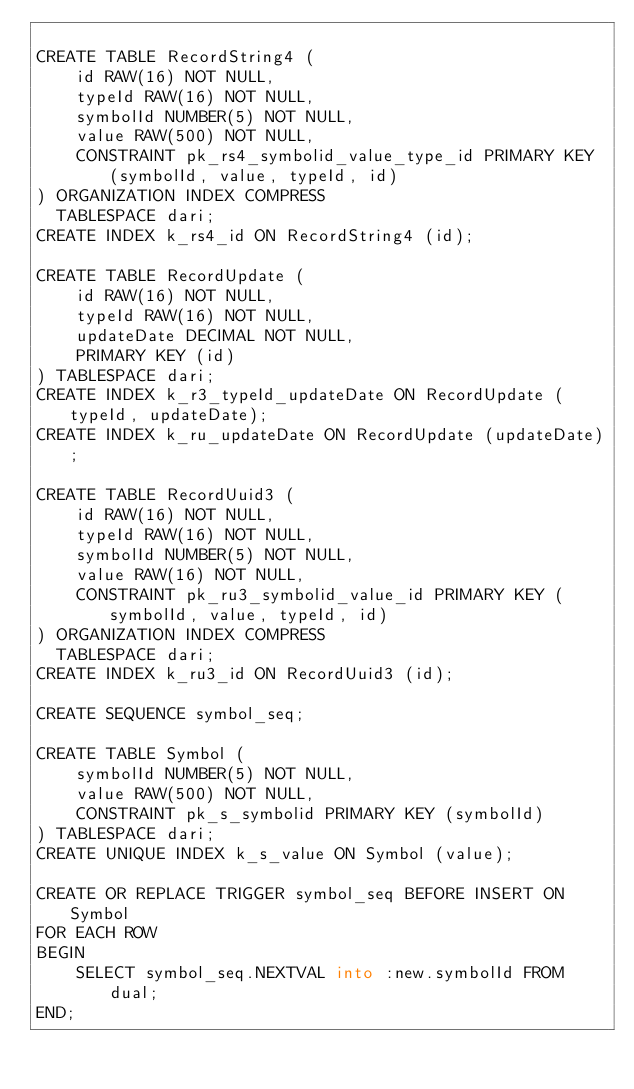Convert code to text. <code><loc_0><loc_0><loc_500><loc_500><_SQL_>
CREATE TABLE RecordString4 (
    id RAW(16) NOT NULL,
    typeId RAW(16) NOT NULL,
    symbolId NUMBER(5) NOT NULL,
    value RAW(500) NOT NULL,
    CONSTRAINT pk_rs4_symbolid_value_type_id PRIMARY KEY (symbolId, value, typeId, id)
) ORGANIZATION INDEX COMPRESS
  TABLESPACE dari;
CREATE INDEX k_rs4_id ON RecordString4 (id);

CREATE TABLE RecordUpdate (
    id RAW(16) NOT NULL,
    typeId RAW(16) NOT NULL,
    updateDate DECIMAL NOT NULL,
    PRIMARY KEY (id)
) TABLESPACE dari;
CREATE INDEX k_r3_typeId_updateDate ON RecordUpdate (typeId, updateDate);
CREATE INDEX k_ru_updateDate ON RecordUpdate (updateDate);

CREATE TABLE RecordUuid3 (
    id RAW(16) NOT NULL,
    typeId RAW(16) NOT NULL,
    symbolId NUMBER(5) NOT NULL,
    value RAW(16) NOT NULL,
    CONSTRAINT pk_ru3_symbolid_value_id PRIMARY KEY (symbolId, value, typeId, id)
) ORGANIZATION INDEX COMPRESS
  TABLESPACE dari;
CREATE INDEX k_ru3_id ON RecordUuid3 (id);

CREATE SEQUENCE symbol_seq;

CREATE TABLE Symbol (
    symbolId NUMBER(5) NOT NULL,
    value RAW(500) NOT NULL,
    CONSTRAINT pk_s_symbolid PRIMARY KEY (symbolId)
) TABLESPACE dari;
CREATE UNIQUE INDEX k_s_value ON Symbol (value);

CREATE OR REPLACE TRIGGER symbol_seq BEFORE INSERT ON Symbol
FOR EACH ROW
BEGIN
    SELECT symbol_seq.NEXTVAL into :new.symbolId FROM dual;
END;

</code> 